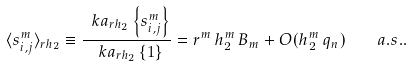Convert formula to latex. <formula><loc_0><loc_0><loc_500><loc_500>\langle s ^ { m } _ { i , j } \rangle _ { r h _ { 2 } } \equiv \frac { \ k a _ { r h _ { 2 } } \left \{ s _ { i , j } ^ { m } \right \} } { \ k a _ { r h _ { 2 } } \left \{ 1 \right \} } = r ^ { m } \, h _ { 2 } ^ { m } \, B _ { m } + O ( h _ { 2 } ^ { m } \, q _ { n } ) \quad a . s . .</formula> 